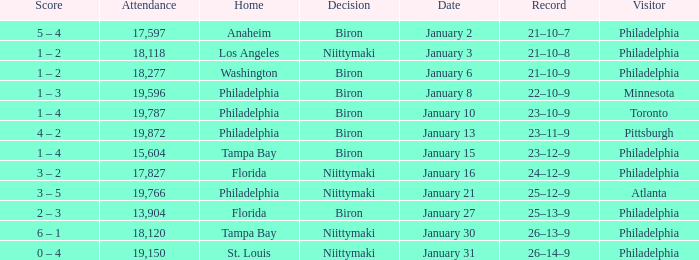Would you be able to parse every entry in this table? {'header': ['Score', 'Attendance', 'Home', 'Decision', 'Date', 'Record', 'Visitor'], 'rows': [['5 – 4', '17,597', 'Anaheim', 'Biron', 'January 2', '21–10–7', 'Philadelphia'], ['1 – 2', '18,118', 'Los Angeles', 'Niittymaki', 'January 3', '21–10–8', 'Philadelphia'], ['1 – 2', '18,277', 'Washington', 'Biron', 'January 6', '21–10–9', 'Philadelphia'], ['1 – 3', '19,596', 'Philadelphia', 'Biron', 'January 8', '22–10–9', 'Minnesota'], ['1 – 4', '19,787', 'Philadelphia', 'Biron', 'January 10', '23–10–9', 'Toronto'], ['4 – 2', '19,872', 'Philadelphia', 'Biron', 'January 13', '23–11–9', 'Pittsburgh'], ['1 – 4', '15,604', 'Tampa Bay', 'Biron', 'January 15', '23–12–9', 'Philadelphia'], ['3 – 2', '17,827', 'Florida', 'Niittymaki', 'January 16', '24–12–9', 'Philadelphia'], ['3 – 5', '19,766', 'Philadelphia', 'Niittymaki', 'January 21', '25–12–9', 'Atlanta'], ['2 – 3', '13,904', 'Florida', 'Biron', 'January 27', '25–13–9', 'Philadelphia'], ['6 – 1', '18,120', 'Tampa Bay', 'Niittymaki', 'January 30', '26–13–9', 'Philadelphia'], ['0 – 4', '19,150', 'St. Louis', 'Niittymaki', 'January 31', '26–14–9', 'Philadelphia']]} What is the decision of the game on January 13? Biron. 